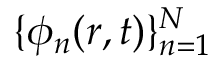<formula> <loc_0><loc_0><loc_500><loc_500>\{ \phi _ { n } ( r , t ) \} _ { n = 1 } ^ { N }</formula> 